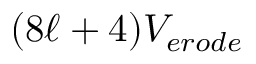Convert formula to latex. <formula><loc_0><loc_0><loc_500><loc_500>( 8 \ell + 4 ) V _ { e r o d e }</formula> 